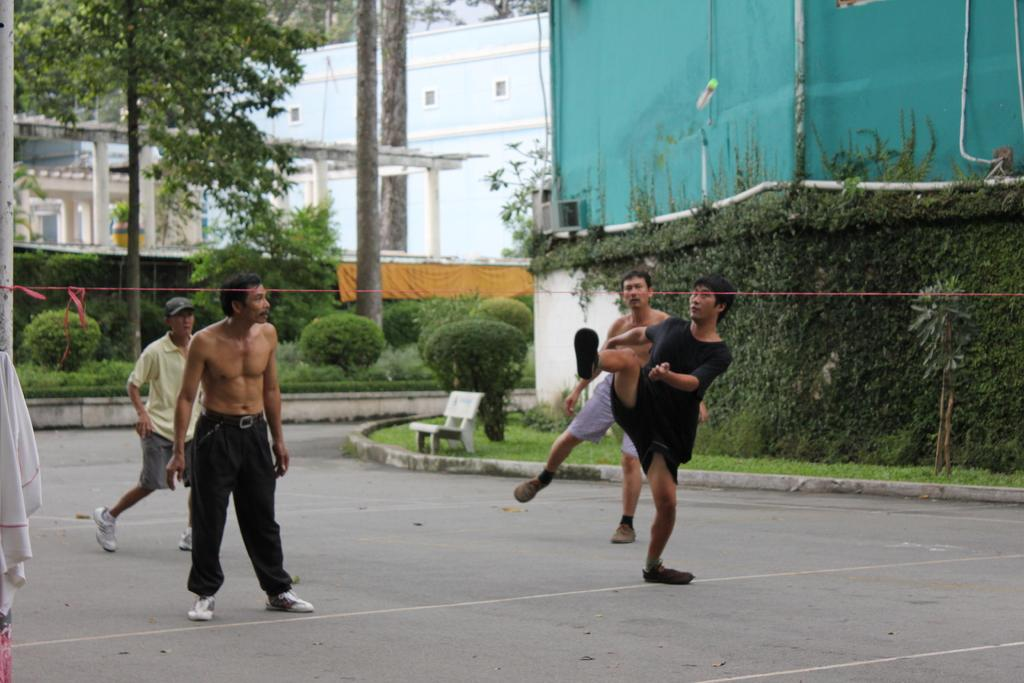How many men are present in the image? There are four men on the ground in the image. What is located on the grass in the image? There is a bench on the grass. What type of items can be seen in the image? Clothes, plants, trees, pillars, a building, and some objects are present in the image. What is visible in the background of the image? The sky is visible in the background of the image. What grade is the table mentioned in the image? There is no table mentioned in the image, so it is not possible to determine its grade. 